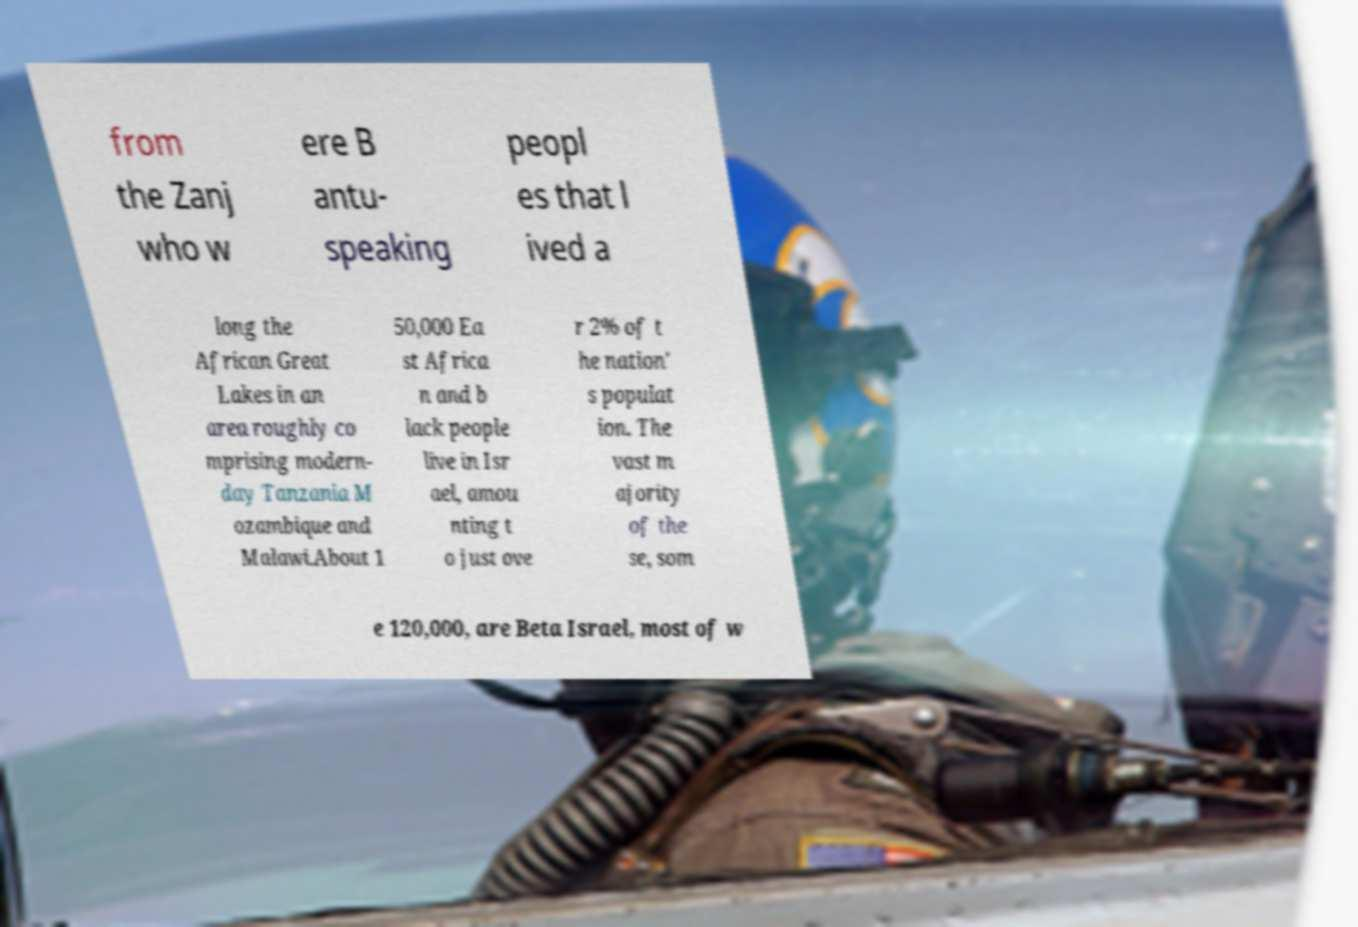There's text embedded in this image that I need extracted. Can you transcribe it verbatim? from the Zanj who w ere B antu- speaking peopl es that l ived a long the African Great Lakes in an area roughly co mprising modern- day Tanzania M ozambique and Malawi.About 1 50,000 Ea st Africa n and b lack people live in Isr ael, amou nting t o just ove r 2% of t he nation' s populat ion. The vast m ajority of the se, som e 120,000, are Beta Israel, most of w 